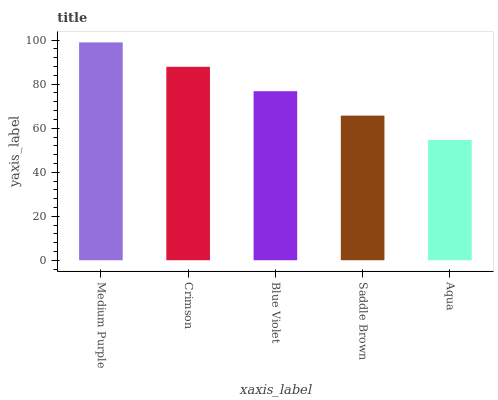Is Crimson the minimum?
Answer yes or no. No. Is Crimson the maximum?
Answer yes or no. No. Is Medium Purple greater than Crimson?
Answer yes or no. Yes. Is Crimson less than Medium Purple?
Answer yes or no. Yes. Is Crimson greater than Medium Purple?
Answer yes or no. No. Is Medium Purple less than Crimson?
Answer yes or no. No. Is Blue Violet the high median?
Answer yes or no. Yes. Is Blue Violet the low median?
Answer yes or no. Yes. Is Saddle Brown the high median?
Answer yes or no. No. Is Crimson the low median?
Answer yes or no. No. 